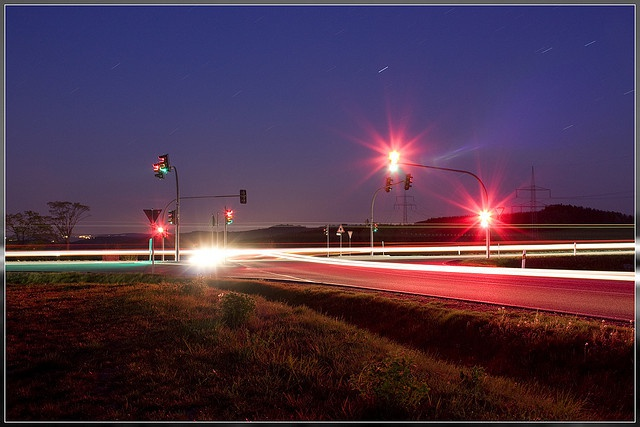Describe the objects in this image and their specific colors. I can see traffic light in gray, brown, salmon, and ivory tones, traffic light in gray, black, maroon, and purple tones, traffic light in gray, maroon, brown, and purple tones, traffic light in gray, black, purple, maroon, and brown tones, and traffic light in gray, black, purple, and brown tones in this image. 